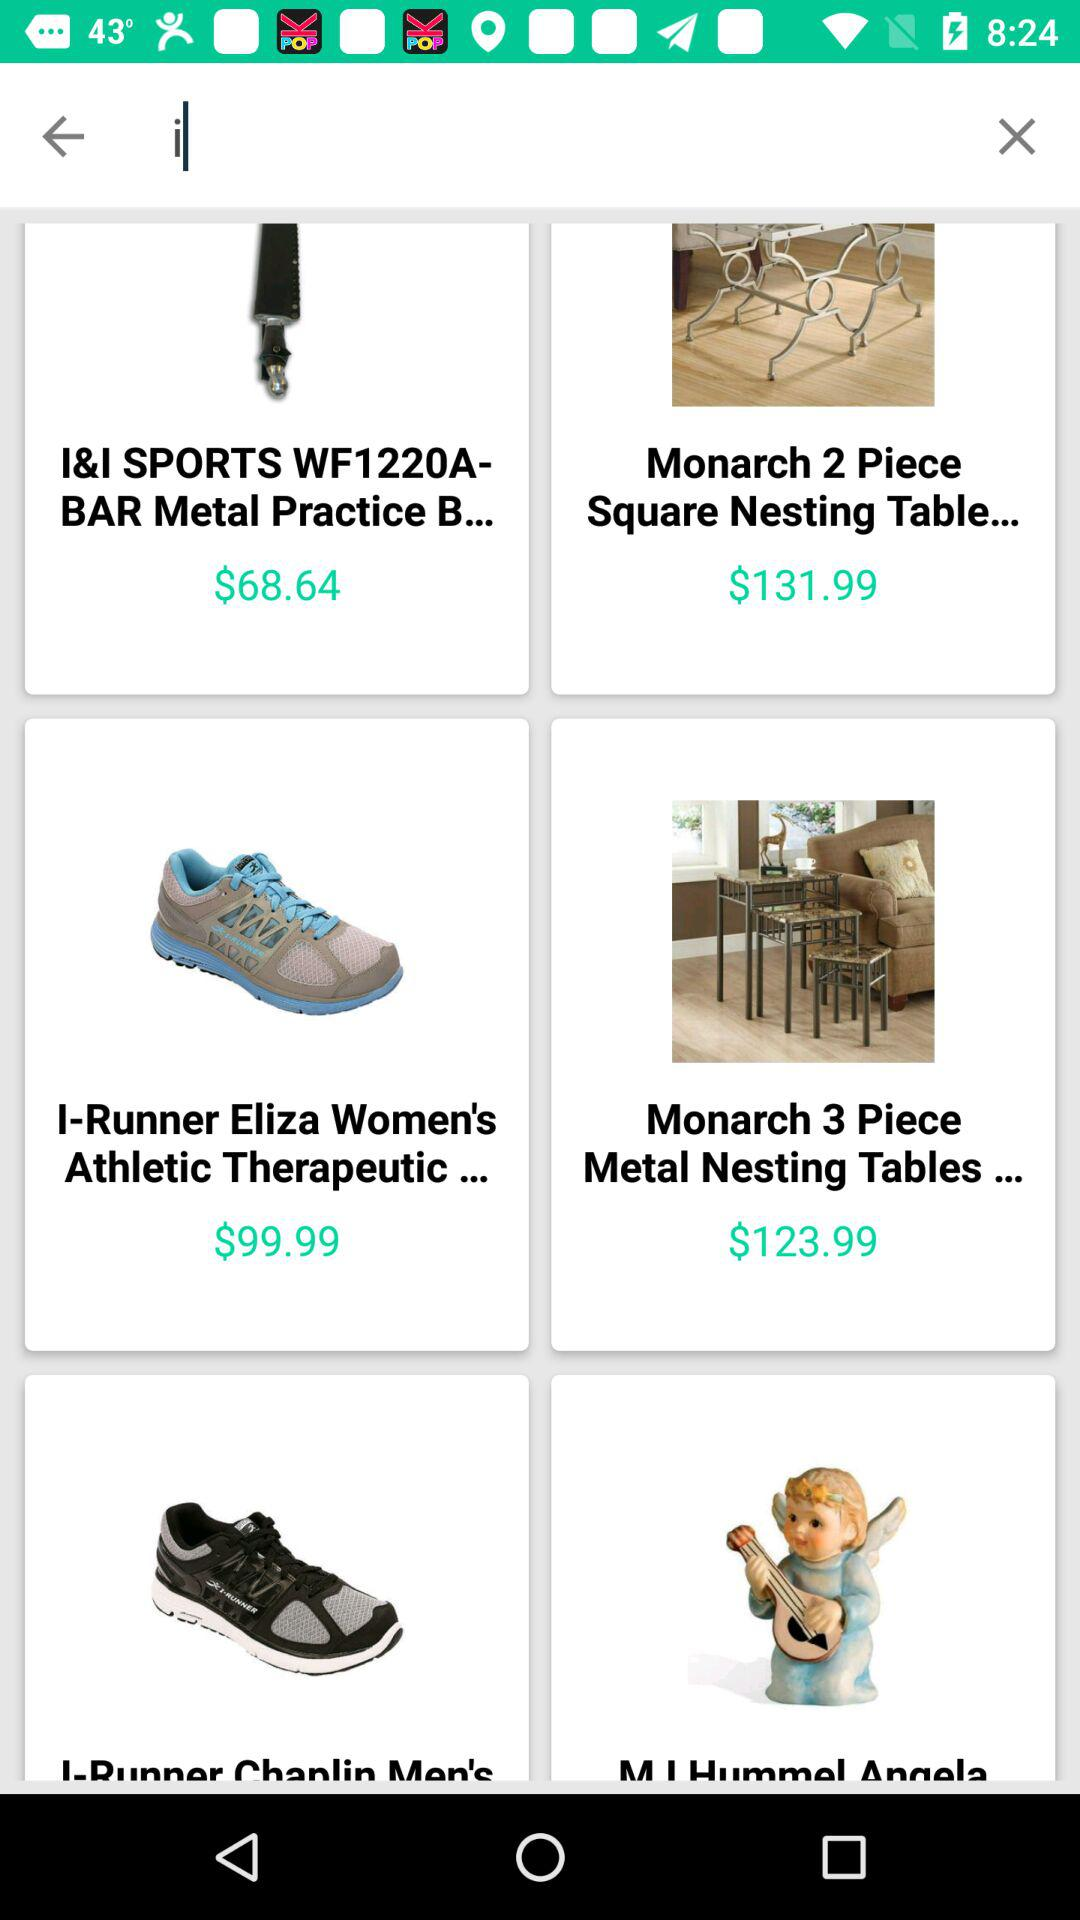What product has a price of $99.99? The product that has a price of $99.99 is "I-Runner Eliza Women's Athletic Therapeutic...". 